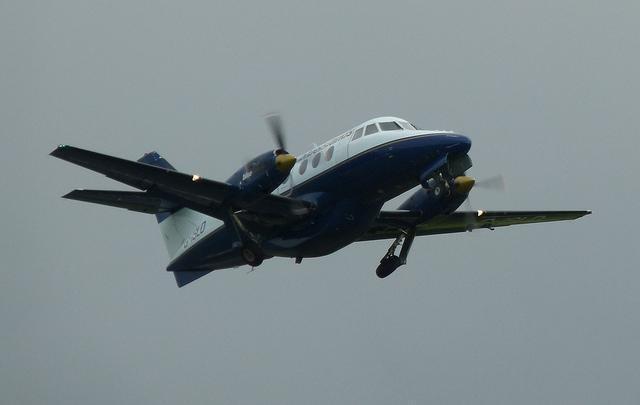How many women are in the room?
Give a very brief answer. 0. 